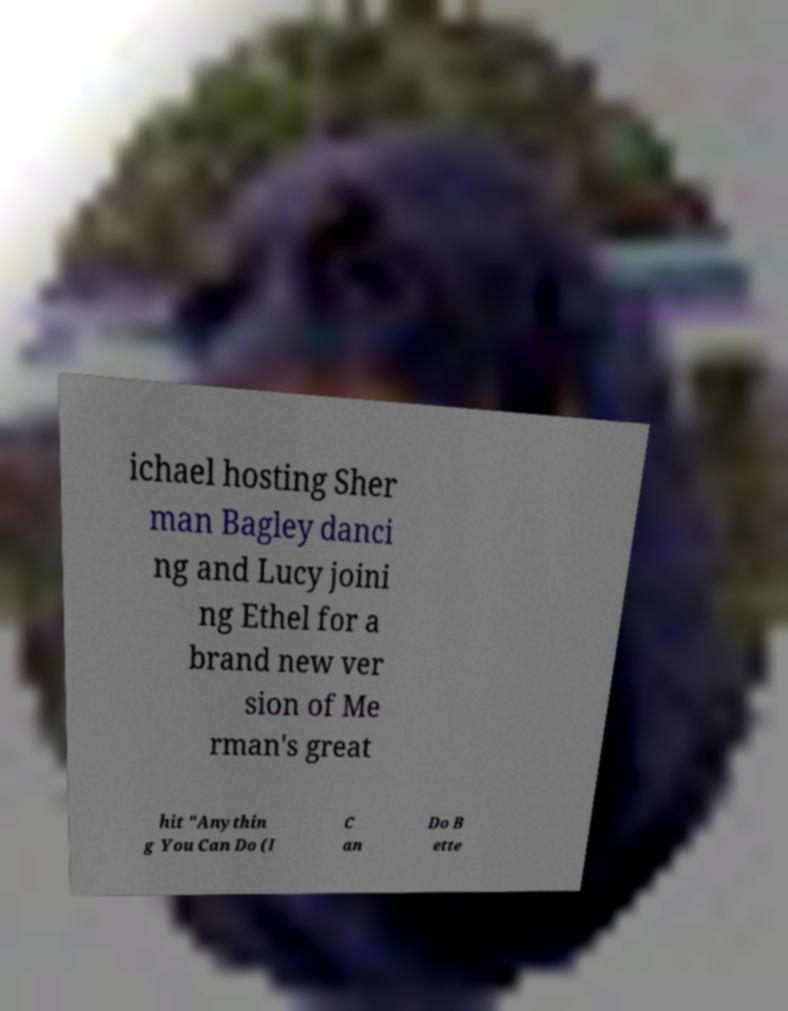Could you extract and type out the text from this image? ichael hosting Sher man Bagley danci ng and Lucy joini ng Ethel for a brand new ver sion of Me rman's great hit "Anythin g You Can Do (I C an Do B ette 